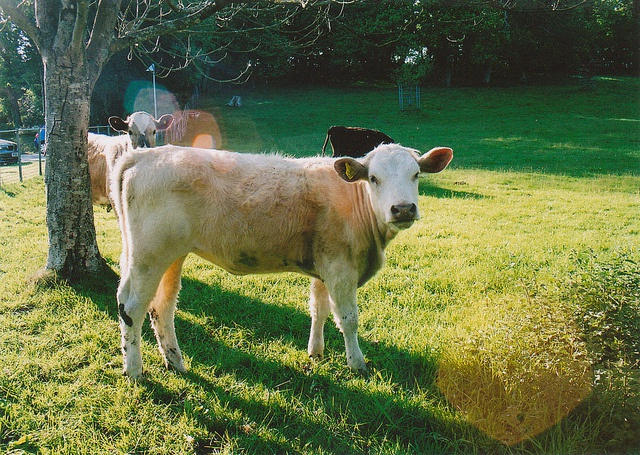Describe the objects in this image and their specific colors. I can see cow in gray, olive, tan, and darkgray tones, cow in gray, lightgray, and darkgray tones, cow in gray, black, and teal tones, car in gray, black, teal, and navy tones, and car in gray, blue, black, and navy tones in this image. 